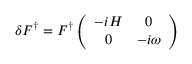<formula> <loc_0><loc_0><loc_500><loc_500>\delta F ^ { \dag } = F ^ { \dag } \left ( \begin{array} { c c } { - i H } & { 0 } \\ { 0 } & { - i \omega } \end{array} \right )</formula> 